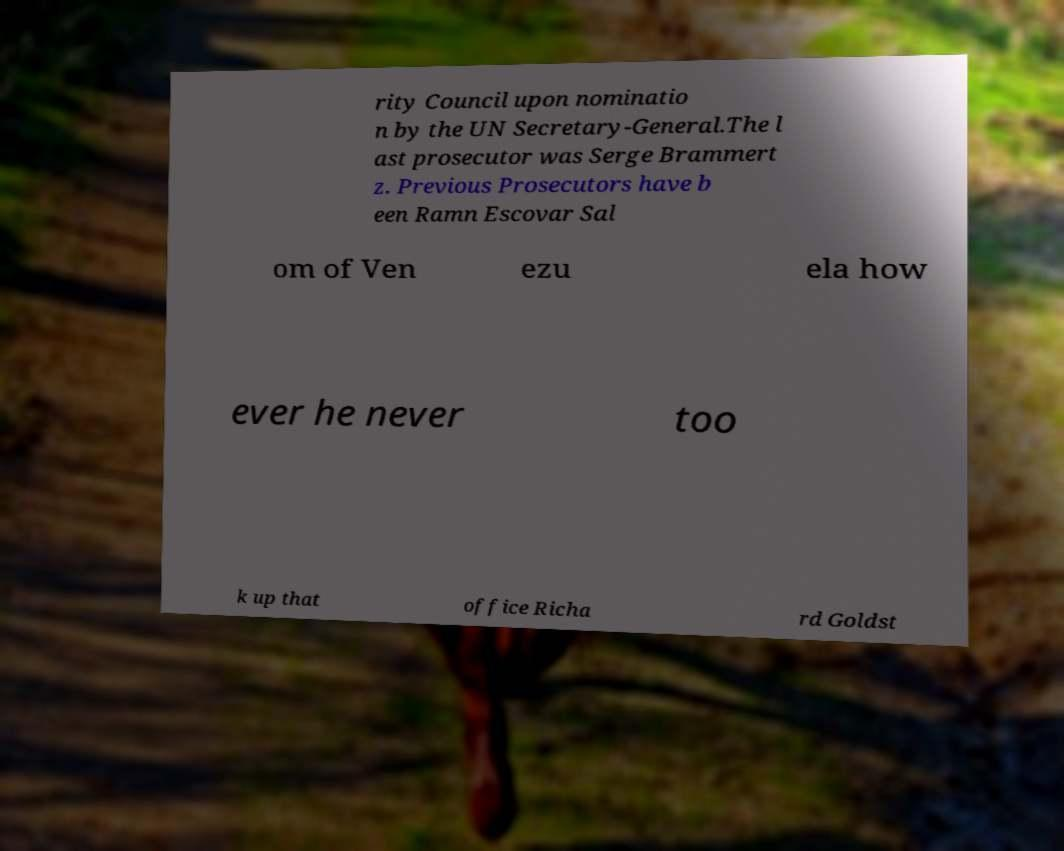Please read and relay the text visible in this image. What does it say? rity Council upon nominatio n by the UN Secretary-General.The l ast prosecutor was Serge Brammert z. Previous Prosecutors have b een Ramn Escovar Sal om of Ven ezu ela how ever he never too k up that office Richa rd Goldst 